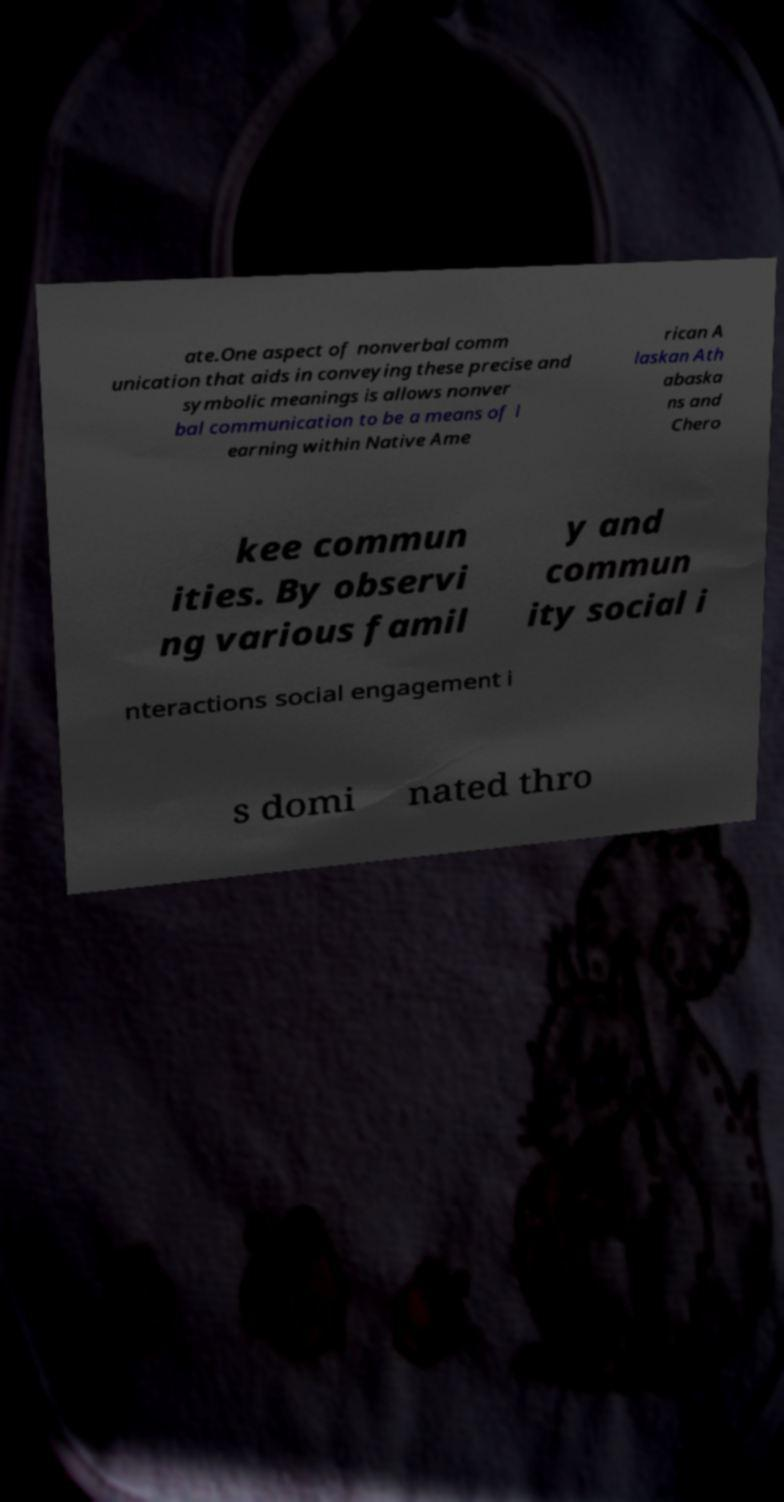Can you accurately transcribe the text from the provided image for me? ate.One aspect of nonverbal comm unication that aids in conveying these precise and symbolic meanings is allows nonver bal communication to be a means of l earning within Native Ame rican A laskan Ath abaska ns and Chero kee commun ities. By observi ng various famil y and commun ity social i nteractions social engagement i s domi nated thro 